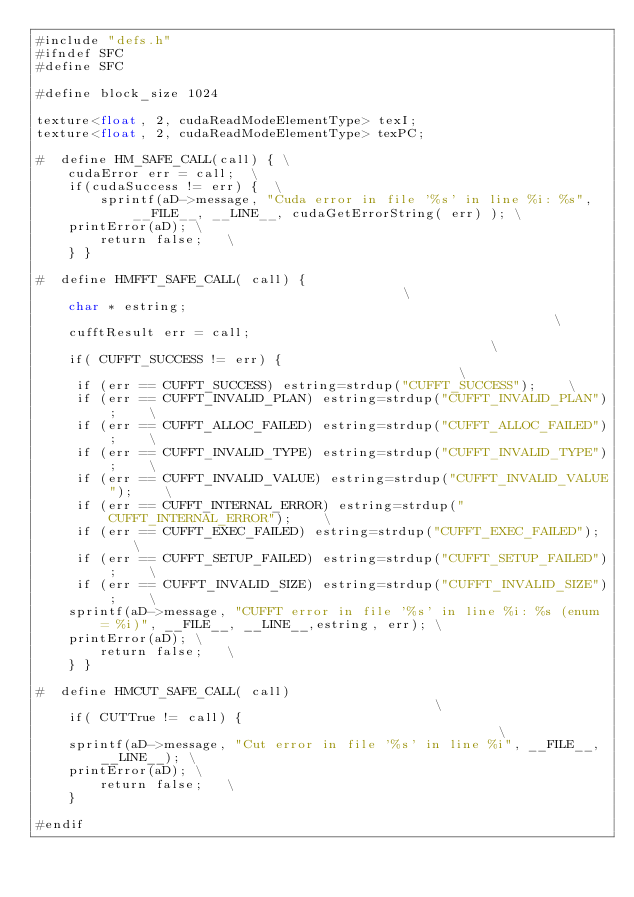Convert code to text. <code><loc_0><loc_0><loc_500><loc_500><_Cuda_>#include "defs.h"
#ifndef SFC
#define SFC

#define block_size 1024

texture<float, 2, cudaReadModeElementType> texI;
texture<float, 2, cudaReadModeElementType> texPC;

#  define HM_SAFE_CALL(call) { \
    cudaError err = call;  \
    if(cudaSuccess != err) {  \
        sprintf(aD->message, "Cuda error in file '%s' in line %i: %s", __FILE__, __LINE__, cudaGetErrorString( err) ); \
		printError(aD); \
        return false;   \
    } }

#  define HMFFT_SAFE_CALL( call) {                                           \
    char * estring;                                                          \
    cufftResult err = call;                                                  \
    if( CUFFT_SUCCESS != err) {                                              \
		 if (err == CUFFT_SUCCESS) estring=strdup("CUFFT_SUCCESS");    \
		 if (err == CUFFT_INVALID_PLAN) estring=strdup("CUFFT_INVALID_PLAN");    \
		 if (err == CUFFT_ALLOC_FAILED) estring=strdup("CUFFT_ALLOC_FAILED");    \
		 if (err == CUFFT_INVALID_TYPE) estring=strdup("CUFFT_INVALID_TYPE");    \
		 if (err == CUFFT_INVALID_VALUE) estring=strdup("CUFFT_INVALID_VALUE");    \
		 if (err == CUFFT_INTERNAL_ERROR) estring=strdup("CUFFT_INTERNAL_ERROR");    \
		 if (err == CUFFT_EXEC_FAILED) estring=strdup("CUFFT_EXEC_FAILED");    \
		 if (err == CUFFT_SETUP_FAILED) estring=strdup("CUFFT_SETUP_FAILED");    \
		 if (err == CUFFT_INVALID_SIZE) estring=strdup("CUFFT_INVALID_SIZE");    \
		sprintf(aD->message, "CUFFT error in file '%s' in line %i: %s (enum = %i)", __FILE__, __LINE__,estring, err); \
		printError(aD); \
        return false;   \
    } }

#  define HMCUT_SAFE_CALL( call)                                               \
    if( CUTTrue != call) {                                                   \
		sprintf(aD->message, "Cut error in file '%s' in line %i", __FILE__, __LINE__); \
		printError(aD); \
        return false;   \
    } 

#endif

</code> 